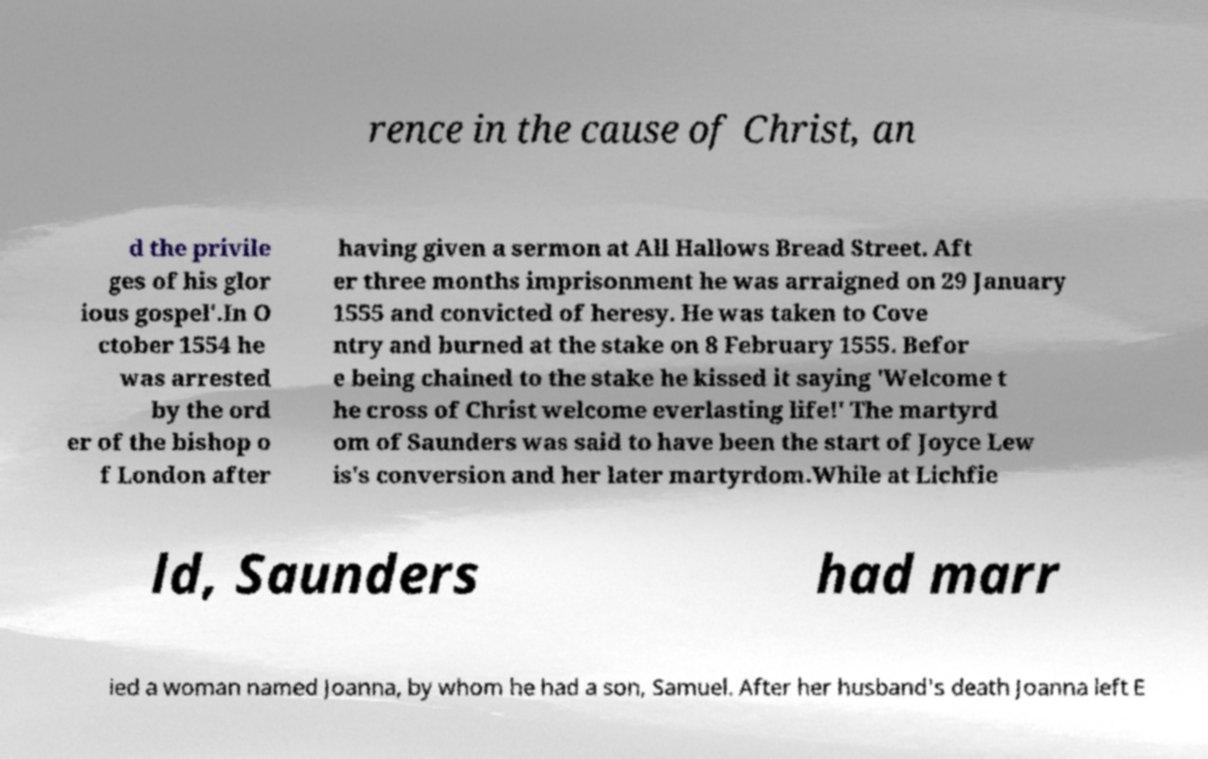Could you assist in decoding the text presented in this image and type it out clearly? rence in the cause of Christ, an d the privile ges of his glor ious gospel'.In O ctober 1554 he was arrested by the ord er of the bishop o f London after having given a sermon at All Hallows Bread Street. Aft er three months imprisonment he was arraigned on 29 January 1555 and convicted of heresy. He was taken to Cove ntry and burned at the stake on 8 February 1555. Befor e being chained to the stake he kissed it saying 'Welcome t he cross of Christ welcome everlasting life!' The martyrd om of Saunders was said to have been the start of Joyce Lew is's conversion and her later martyrdom.While at Lichfie ld, Saunders had marr ied a woman named Joanna, by whom he had a son, Samuel. After her husband's death Joanna left E 